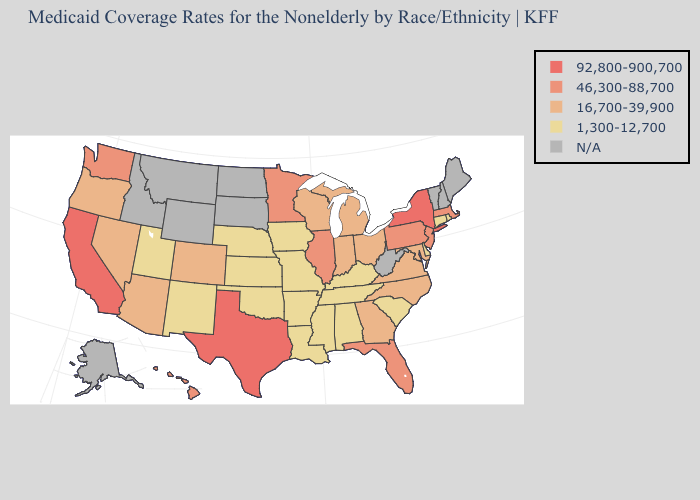What is the lowest value in the MidWest?
Concise answer only. 1,300-12,700. Does New Mexico have the highest value in the USA?
Write a very short answer. No. Does the first symbol in the legend represent the smallest category?
Short answer required. No. Name the states that have a value in the range N/A?
Be succinct. Alaska, Idaho, Maine, Montana, New Hampshire, North Dakota, South Dakota, Vermont, West Virginia, Wyoming. What is the highest value in the USA?
Write a very short answer. 92,800-900,700. What is the highest value in the West ?
Be succinct. 92,800-900,700. Does the first symbol in the legend represent the smallest category?
Keep it brief. No. Does the map have missing data?
Concise answer only. Yes. Name the states that have a value in the range 46,300-88,700?
Write a very short answer. Florida, Hawaii, Illinois, Massachusetts, Minnesota, New Jersey, Pennsylvania, Washington. What is the highest value in the USA?
Short answer required. 92,800-900,700. Does Arkansas have the highest value in the South?
Quick response, please. No. Among the states that border Arizona , which have the highest value?
Give a very brief answer. California. What is the highest value in states that border New Hampshire?
Concise answer only. 46,300-88,700. What is the value of Alaska?
Write a very short answer. N/A. What is the lowest value in the USA?
Quick response, please. 1,300-12,700. 